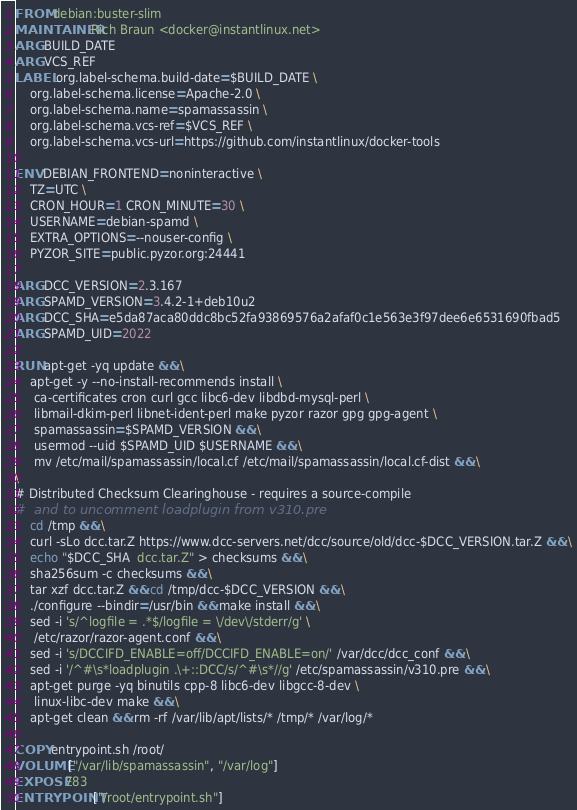<code> <loc_0><loc_0><loc_500><loc_500><_Dockerfile_>FROM debian:buster-slim
MAINTAINER Rich Braun <docker@instantlinux.net>
ARG BUILD_DATE
ARG VCS_REF
LABEL org.label-schema.build-date=$BUILD_DATE \
    org.label-schema.license=Apache-2.0 \
    org.label-schema.name=spamassassin \
    org.label-schema.vcs-ref=$VCS_REF \
    org.label-schema.vcs-url=https://github.com/instantlinux/docker-tools

ENV DEBIAN_FRONTEND=noninteractive \
    TZ=UTC \
    CRON_HOUR=1 CRON_MINUTE=30 \
    USERNAME=debian-spamd \
    EXTRA_OPTIONS=--nouser-config \
    PYZOR_SITE=public.pyzor.org:24441

ARG DCC_VERSION=2.3.167
ARG SPAMD_VERSION=3.4.2-1+deb10u2
ARG DCC_SHA=e5da87aca80ddc8bc52fa93869576a2afaf0c1e563e3f97dee6e6531690fbad5
ARG SPAMD_UID=2022

RUN apt-get -yq update && \
    apt-get -y --no-install-recommends install \
     ca-certificates cron curl gcc libc6-dev libdbd-mysql-perl \
     libmail-dkim-perl libnet-ident-perl make pyzor razor gpg gpg-agent \
     spamassassin=$SPAMD_VERSION && \
     usermod --uid $SPAMD_UID $USERNAME && \
     mv /etc/mail/spamassassin/local.cf /etc/mail/spamassassin/local.cf-dist && \
\
# Distributed Checksum Clearinghouse - requires a source-compile
#  and to uncomment loadplugin from v310.pre
    cd /tmp && \
    curl -sLo dcc.tar.Z https://www.dcc-servers.net/dcc/source/old/dcc-$DCC_VERSION.tar.Z && \
    echo "$DCC_SHA  dcc.tar.Z" > checksums && \
    sha256sum -c checksums && \
    tar xzf dcc.tar.Z && cd /tmp/dcc-$DCC_VERSION && \
    ./configure --bindir=/usr/bin && make install && \
    sed -i 's/^logfile = .*$/logfile = \/dev\/stderr/g' \
     /etc/razor/razor-agent.conf && \
    sed -i 's/DCCIFD_ENABLE=off/DCCIFD_ENABLE=on/' /var/dcc/dcc_conf && \
    sed -i '/^#\s*loadplugin .\+::DCC/s/^#\s*//g' /etc/spamassassin/v310.pre && \
    apt-get purge -yq binutils cpp-8 libc6-dev libgcc-8-dev \
     linux-libc-dev make && \
    apt-get clean && rm -rf /var/lib/apt/lists/* /tmp/* /var/log/*

COPY entrypoint.sh /root/
VOLUME ["/var/lib/spamassassin", "/var/log"]
EXPOSE 783
ENTRYPOINT ["/root/entrypoint.sh"]
</code> 